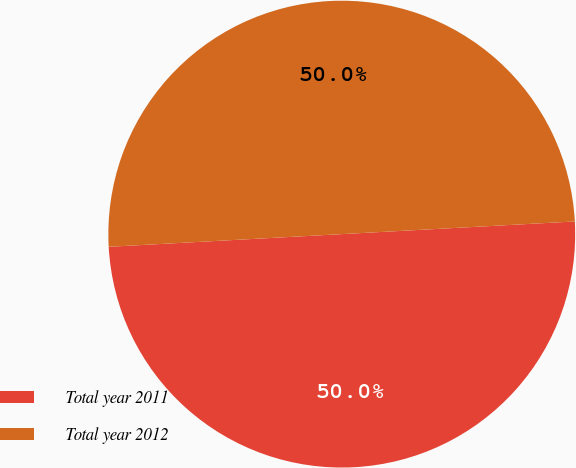Convert chart to OTSL. <chart><loc_0><loc_0><loc_500><loc_500><pie_chart><fcel>Total year 2011<fcel>Total year 2012<nl><fcel>50.0%<fcel>50.0%<nl></chart> 